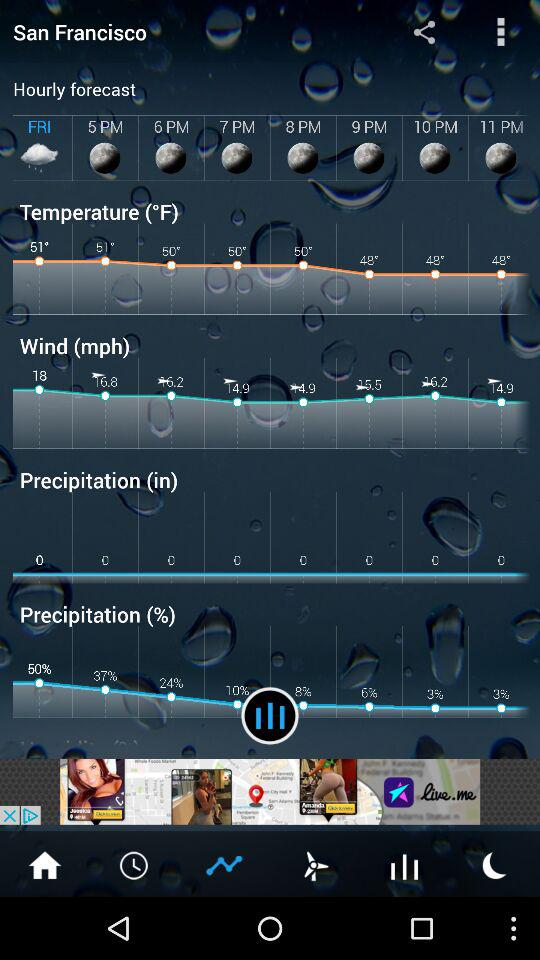What is the wind speed on Friday at 5 p.m.? The wind speed on Friday at 5 p.m. is 16.8 mph. 